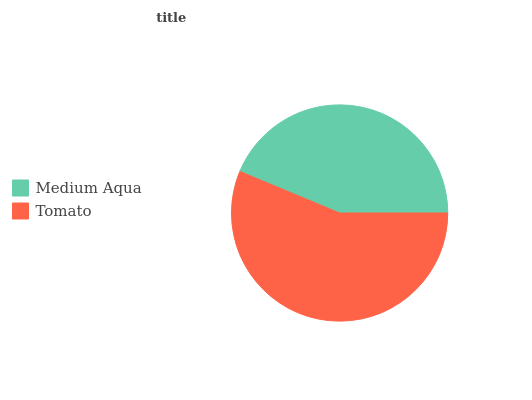Is Medium Aqua the minimum?
Answer yes or no. Yes. Is Tomato the maximum?
Answer yes or no. Yes. Is Tomato the minimum?
Answer yes or no. No. Is Tomato greater than Medium Aqua?
Answer yes or no. Yes. Is Medium Aqua less than Tomato?
Answer yes or no. Yes. Is Medium Aqua greater than Tomato?
Answer yes or no. No. Is Tomato less than Medium Aqua?
Answer yes or no. No. Is Tomato the high median?
Answer yes or no. Yes. Is Medium Aqua the low median?
Answer yes or no. Yes. Is Medium Aqua the high median?
Answer yes or no. No. Is Tomato the low median?
Answer yes or no. No. 